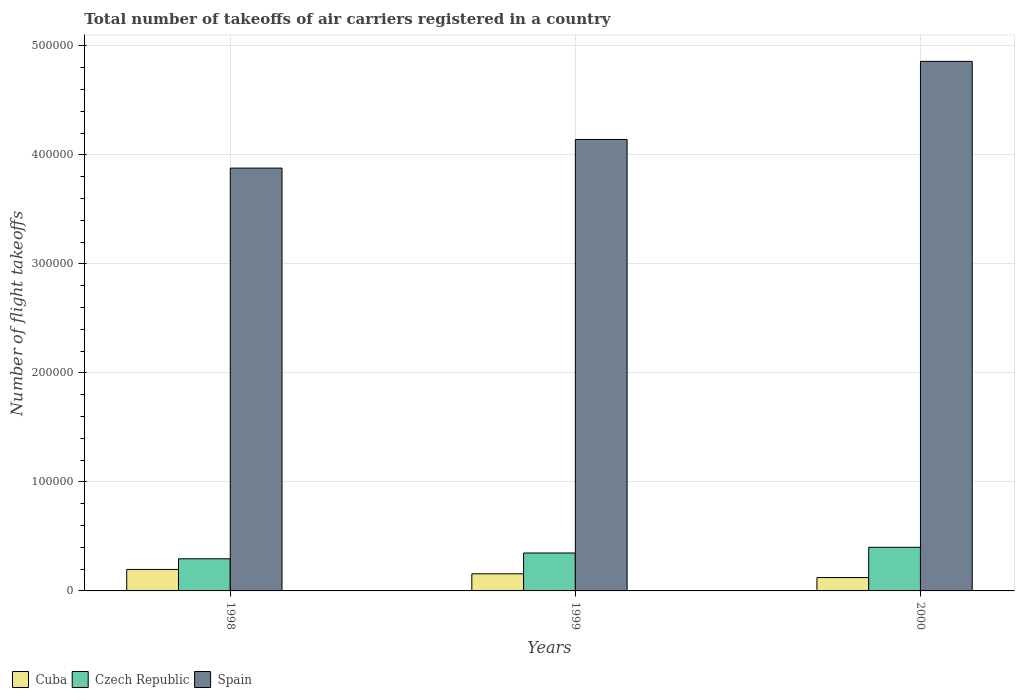How many different coloured bars are there?
Offer a terse response. 3. How many groups of bars are there?
Your answer should be very brief. 3. Are the number of bars per tick equal to the number of legend labels?
Provide a succinct answer. Yes. What is the label of the 1st group of bars from the left?
Ensure brevity in your answer.  1998. What is the total number of flight takeoffs in Cuba in 1998?
Offer a terse response. 1.97e+04. Across all years, what is the maximum total number of flight takeoffs in Cuba?
Ensure brevity in your answer.  1.97e+04. Across all years, what is the minimum total number of flight takeoffs in Cuba?
Provide a succinct answer. 1.23e+04. In which year was the total number of flight takeoffs in Czech Republic minimum?
Your response must be concise. 1998. What is the total total number of flight takeoffs in Cuba in the graph?
Give a very brief answer. 4.77e+04. What is the difference between the total number of flight takeoffs in Cuba in 1998 and that in 2000?
Ensure brevity in your answer.  7436. What is the difference between the total number of flight takeoffs in Czech Republic in 1998 and the total number of flight takeoffs in Cuba in 1999?
Your answer should be compact. 1.38e+04. What is the average total number of flight takeoffs in Czech Republic per year?
Provide a short and direct response. 3.48e+04. In the year 2000, what is the difference between the total number of flight takeoffs in Cuba and total number of flight takeoffs in Czech Republic?
Make the answer very short. -2.78e+04. What is the ratio of the total number of flight takeoffs in Czech Republic in 1998 to that in 1999?
Your response must be concise. 0.85. What is the difference between the highest and the second highest total number of flight takeoffs in Spain?
Offer a terse response. 7.17e+04. What is the difference between the highest and the lowest total number of flight takeoffs in Spain?
Provide a short and direct response. 9.80e+04. In how many years, is the total number of flight takeoffs in Czech Republic greater than the average total number of flight takeoffs in Czech Republic taken over all years?
Make the answer very short. 2. Is the sum of the total number of flight takeoffs in Spain in 1998 and 1999 greater than the maximum total number of flight takeoffs in Cuba across all years?
Keep it short and to the point. Yes. What does the 1st bar from the left in 1999 represents?
Give a very brief answer. Cuba. What does the 2nd bar from the right in 1999 represents?
Ensure brevity in your answer.  Czech Republic. Is it the case that in every year, the sum of the total number of flight takeoffs in Spain and total number of flight takeoffs in Cuba is greater than the total number of flight takeoffs in Czech Republic?
Ensure brevity in your answer.  Yes. How many years are there in the graph?
Give a very brief answer. 3. Are the values on the major ticks of Y-axis written in scientific E-notation?
Make the answer very short. No. Does the graph contain any zero values?
Provide a short and direct response. No. Does the graph contain grids?
Keep it short and to the point. Yes. Where does the legend appear in the graph?
Provide a succinct answer. Bottom left. How many legend labels are there?
Offer a terse response. 3. How are the legend labels stacked?
Keep it short and to the point. Horizontal. What is the title of the graph?
Offer a very short reply. Total number of takeoffs of air carriers registered in a country. Does "Norway" appear as one of the legend labels in the graph?
Provide a succinct answer. No. What is the label or title of the Y-axis?
Your answer should be very brief. Number of flight takeoffs. What is the Number of flight takeoffs in Cuba in 1998?
Make the answer very short. 1.97e+04. What is the Number of flight takeoffs in Czech Republic in 1998?
Ensure brevity in your answer.  2.95e+04. What is the Number of flight takeoffs of Spain in 1998?
Provide a short and direct response. 3.88e+05. What is the Number of flight takeoffs of Cuba in 1999?
Your answer should be very brief. 1.57e+04. What is the Number of flight takeoffs in Czech Republic in 1999?
Your response must be concise. 3.48e+04. What is the Number of flight takeoffs in Spain in 1999?
Make the answer very short. 4.14e+05. What is the Number of flight takeoffs in Cuba in 2000?
Make the answer very short. 1.23e+04. What is the Number of flight takeoffs of Czech Republic in 2000?
Give a very brief answer. 4.00e+04. What is the Number of flight takeoffs of Spain in 2000?
Keep it short and to the point. 4.86e+05. Across all years, what is the maximum Number of flight takeoffs of Cuba?
Your answer should be compact. 1.97e+04. Across all years, what is the maximum Number of flight takeoffs of Czech Republic?
Ensure brevity in your answer.  4.00e+04. Across all years, what is the maximum Number of flight takeoffs of Spain?
Offer a very short reply. 4.86e+05. Across all years, what is the minimum Number of flight takeoffs in Cuba?
Make the answer very short. 1.23e+04. Across all years, what is the minimum Number of flight takeoffs of Czech Republic?
Offer a terse response. 2.95e+04. Across all years, what is the minimum Number of flight takeoffs of Spain?
Your response must be concise. 3.88e+05. What is the total Number of flight takeoffs of Cuba in the graph?
Give a very brief answer. 4.77e+04. What is the total Number of flight takeoffs of Czech Republic in the graph?
Ensure brevity in your answer.  1.04e+05. What is the total Number of flight takeoffs of Spain in the graph?
Your answer should be compact. 1.29e+06. What is the difference between the Number of flight takeoffs of Cuba in 1998 and that in 1999?
Offer a very short reply. 4000. What is the difference between the Number of flight takeoffs in Czech Republic in 1998 and that in 1999?
Offer a very short reply. -5300. What is the difference between the Number of flight takeoffs of Spain in 1998 and that in 1999?
Offer a very short reply. -2.63e+04. What is the difference between the Number of flight takeoffs in Cuba in 1998 and that in 2000?
Make the answer very short. 7436. What is the difference between the Number of flight takeoffs in Czech Republic in 1998 and that in 2000?
Your response must be concise. -1.05e+04. What is the difference between the Number of flight takeoffs in Spain in 1998 and that in 2000?
Offer a very short reply. -9.80e+04. What is the difference between the Number of flight takeoffs in Cuba in 1999 and that in 2000?
Provide a succinct answer. 3436. What is the difference between the Number of flight takeoffs in Czech Republic in 1999 and that in 2000?
Your response must be concise. -5227. What is the difference between the Number of flight takeoffs in Spain in 1999 and that in 2000?
Keep it short and to the point. -7.17e+04. What is the difference between the Number of flight takeoffs of Cuba in 1998 and the Number of flight takeoffs of Czech Republic in 1999?
Make the answer very short. -1.51e+04. What is the difference between the Number of flight takeoffs of Cuba in 1998 and the Number of flight takeoffs of Spain in 1999?
Provide a succinct answer. -3.94e+05. What is the difference between the Number of flight takeoffs of Czech Republic in 1998 and the Number of flight takeoffs of Spain in 1999?
Provide a short and direct response. -3.85e+05. What is the difference between the Number of flight takeoffs of Cuba in 1998 and the Number of flight takeoffs of Czech Republic in 2000?
Make the answer very short. -2.03e+04. What is the difference between the Number of flight takeoffs of Cuba in 1998 and the Number of flight takeoffs of Spain in 2000?
Your answer should be very brief. -4.66e+05. What is the difference between the Number of flight takeoffs in Czech Republic in 1998 and the Number of flight takeoffs in Spain in 2000?
Offer a very short reply. -4.56e+05. What is the difference between the Number of flight takeoffs of Cuba in 1999 and the Number of flight takeoffs of Czech Republic in 2000?
Your answer should be compact. -2.43e+04. What is the difference between the Number of flight takeoffs in Cuba in 1999 and the Number of flight takeoffs in Spain in 2000?
Provide a succinct answer. -4.70e+05. What is the difference between the Number of flight takeoffs in Czech Republic in 1999 and the Number of flight takeoffs in Spain in 2000?
Your answer should be compact. -4.51e+05. What is the average Number of flight takeoffs of Cuba per year?
Ensure brevity in your answer.  1.59e+04. What is the average Number of flight takeoffs in Czech Republic per year?
Keep it short and to the point. 3.48e+04. What is the average Number of flight takeoffs of Spain per year?
Offer a very short reply. 4.29e+05. In the year 1998, what is the difference between the Number of flight takeoffs in Cuba and Number of flight takeoffs in Czech Republic?
Your answer should be compact. -9800. In the year 1998, what is the difference between the Number of flight takeoffs in Cuba and Number of flight takeoffs in Spain?
Offer a terse response. -3.68e+05. In the year 1998, what is the difference between the Number of flight takeoffs of Czech Republic and Number of flight takeoffs of Spain?
Give a very brief answer. -3.58e+05. In the year 1999, what is the difference between the Number of flight takeoffs of Cuba and Number of flight takeoffs of Czech Republic?
Your answer should be compact. -1.91e+04. In the year 1999, what is the difference between the Number of flight takeoffs of Cuba and Number of flight takeoffs of Spain?
Make the answer very short. -3.98e+05. In the year 1999, what is the difference between the Number of flight takeoffs in Czech Republic and Number of flight takeoffs in Spain?
Offer a very short reply. -3.79e+05. In the year 2000, what is the difference between the Number of flight takeoffs in Cuba and Number of flight takeoffs in Czech Republic?
Your answer should be compact. -2.78e+04. In the year 2000, what is the difference between the Number of flight takeoffs in Cuba and Number of flight takeoffs in Spain?
Provide a succinct answer. -4.74e+05. In the year 2000, what is the difference between the Number of flight takeoffs in Czech Republic and Number of flight takeoffs in Spain?
Keep it short and to the point. -4.46e+05. What is the ratio of the Number of flight takeoffs of Cuba in 1998 to that in 1999?
Offer a very short reply. 1.25. What is the ratio of the Number of flight takeoffs of Czech Republic in 1998 to that in 1999?
Keep it short and to the point. 0.85. What is the ratio of the Number of flight takeoffs of Spain in 1998 to that in 1999?
Keep it short and to the point. 0.94. What is the ratio of the Number of flight takeoffs in Cuba in 1998 to that in 2000?
Make the answer very short. 1.61. What is the ratio of the Number of flight takeoffs in Czech Republic in 1998 to that in 2000?
Make the answer very short. 0.74. What is the ratio of the Number of flight takeoffs in Spain in 1998 to that in 2000?
Provide a short and direct response. 0.8. What is the ratio of the Number of flight takeoffs of Cuba in 1999 to that in 2000?
Offer a very short reply. 1.28. What is the ratio of the Number of flight takeoffs in Czech Republic in 1999 to that in 2000?
Offer a very short reply. 0.87. What is the ratio of the Number of flight takeoffs in Spain in 1999 to that in 2000?
Your answer should be compact. 0.85. What is the difference between the highest and the second highest Number of flight takeoffs of Cuba?
Offer a very short reply. 4000. What is the difference between the highest and the second highest Number of flight takeoffs of Czech Republic?
Give a very brief answer. 5227. What is the difference between the highest and the second highest Number of flight takeoffs in Spain?
Your answer should be compact. 7.17e+04. What is the difference between the highest and the lowest Number of flight takeoffs of Cuba?
Offer a very short reply. 7436. What is the difference between the highest and the lowest Number of flight takeoffs in Czech Republic?
Your answer should be compact. 1.05e+04. What is the difference between the highest and the lowest Number of flight takeoffs in Spain?
Give a very brief answer. 9.80e+04. 